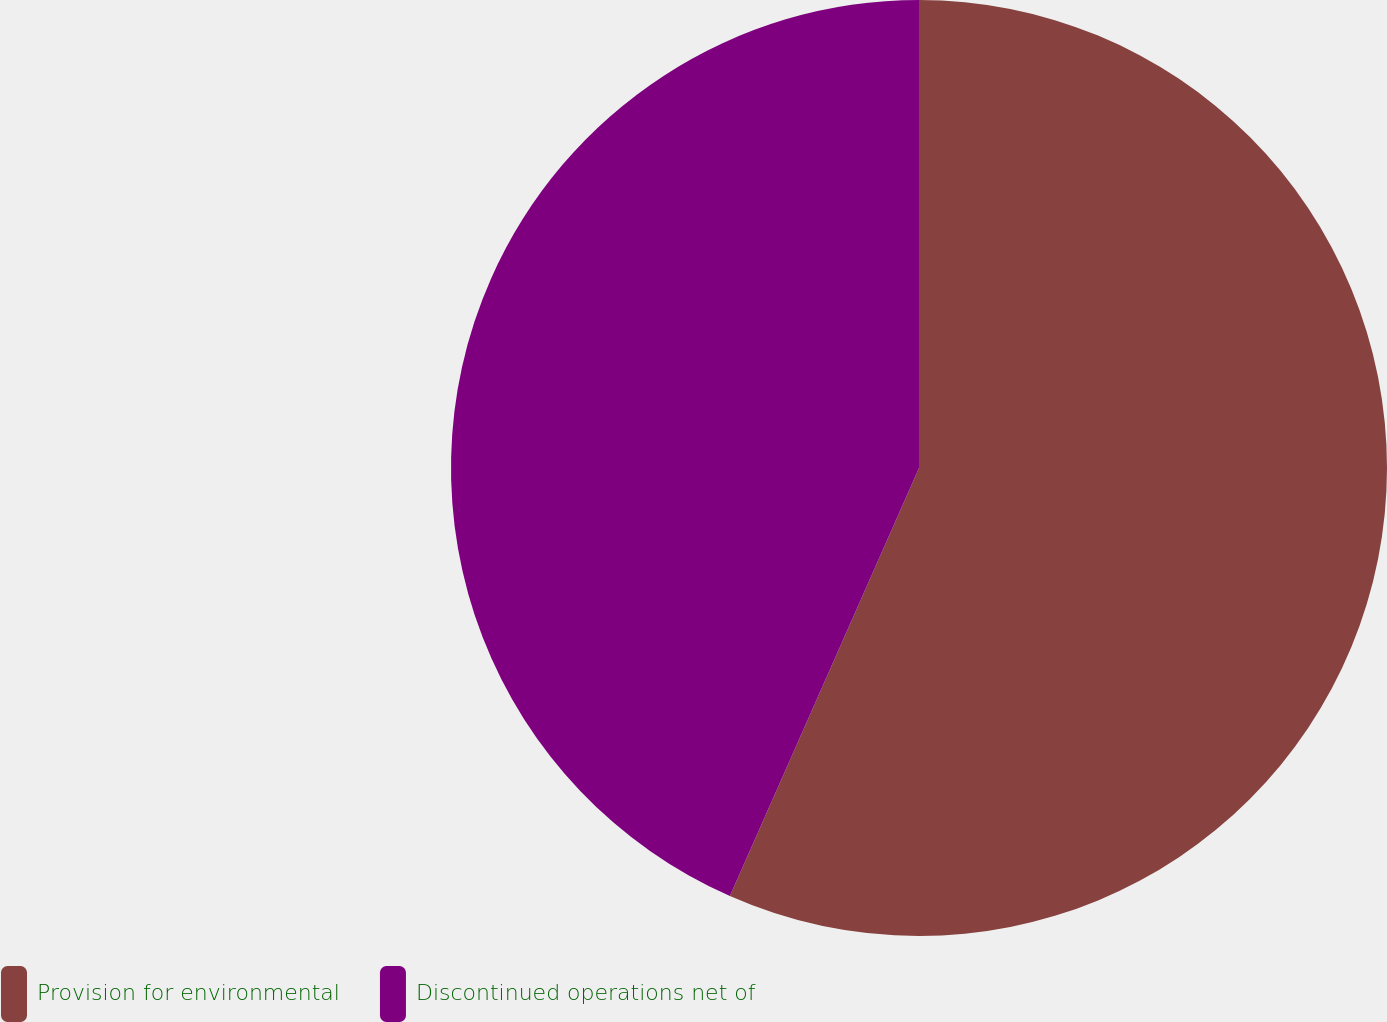Convert chart. <chart><loc_0><loc_0><loc_500><loc_500><pie_chart><fcel>Provision for environmental<fcel>Discontinued operations net of<nl><fcel>56.62%<fcel>43.38%<nl></chart> 